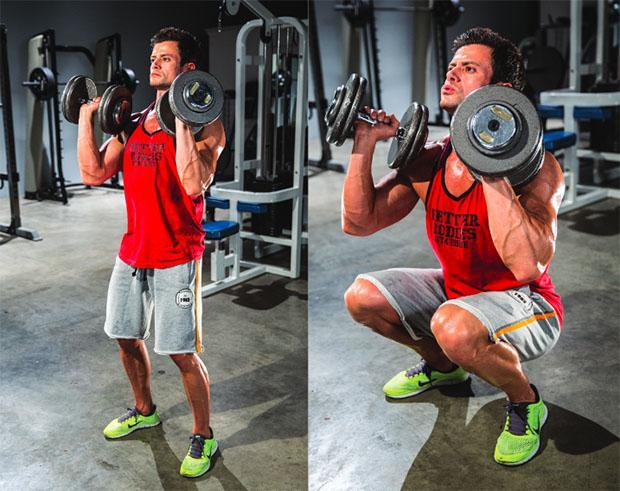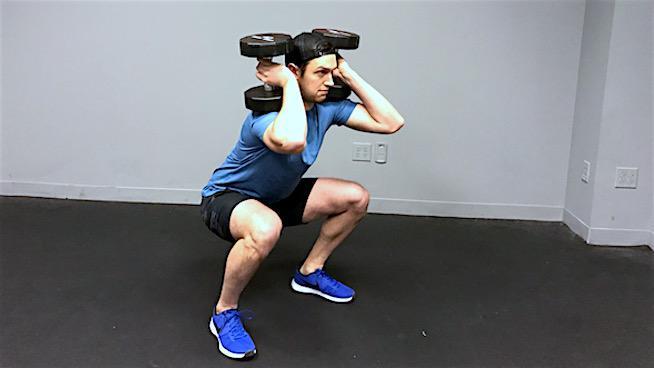The first image is the image on the left, the second image is the image on the right. For the images shown, is this caption "A single person is lifting weights in each of the images." true? Answer yes or no. No. The first image is the image on the left, the second image is the image on the right. Assess this claim about the two images: "A woman is lifting weights in a squat position.". Correct or not? Answer yes or no. No. 